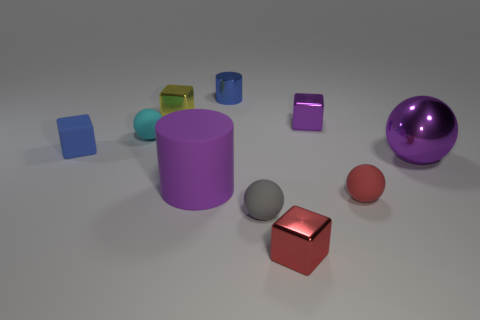There is a tiny blue thing that is right of the sphere to the left of the tiny yellow object; what is its shape? cylinder 